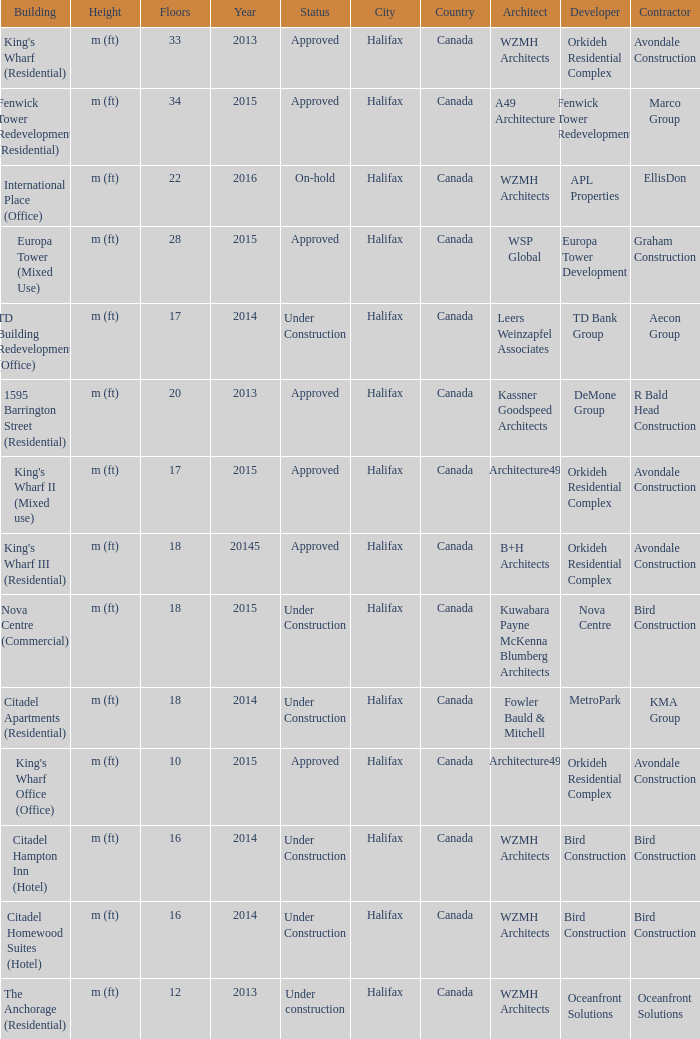What is the status of the building with less than 18 floors and later than 2013? Under Construction, Approved, Approved, Under Construction, Under Construction. 